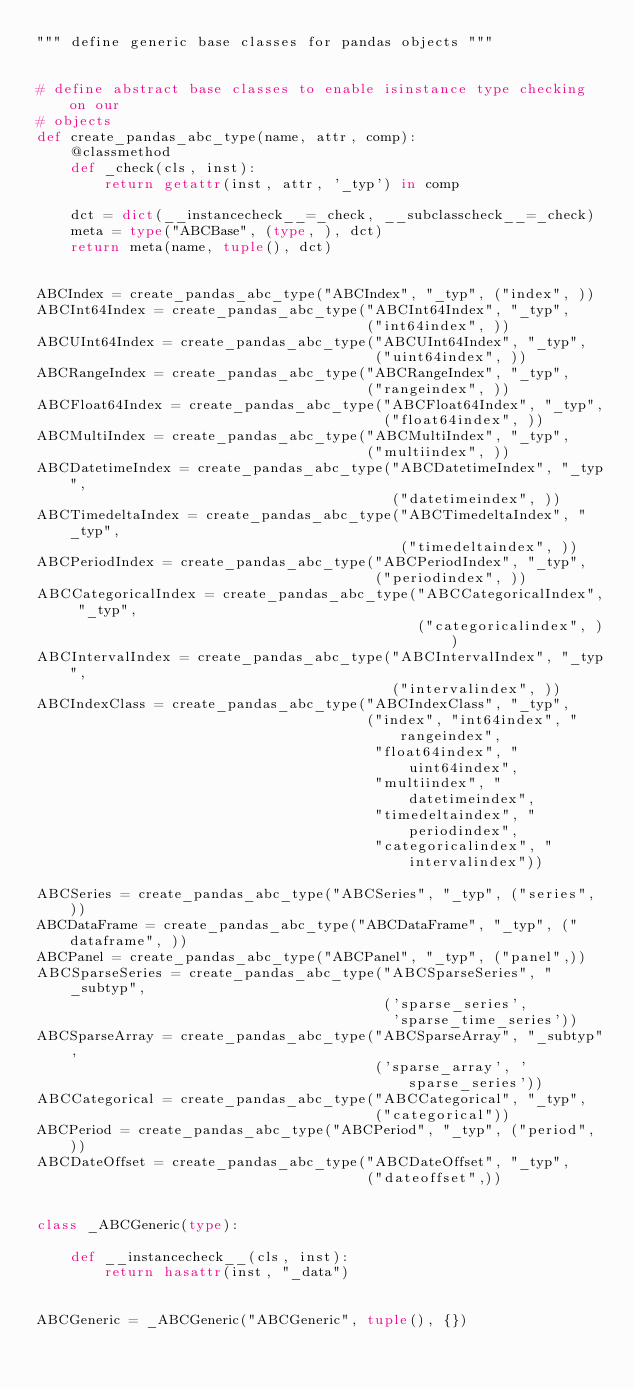<code> <loc_0><loc_0><loc_500><loc_500><_Python_>""" define generic base classes for pandas objects """


# define abstract base classes to enable isinstance type checking on our
# objects
def create_pandas_abc_type(name, attr, comp):
    @classmethod
    def _check(cls, inst):
        return getattr(inst, attr, '_typ') in comp

    dct = dict(__instancecheck__=_check, __subclasscheck__=_check)
    meta = type("ABCBase", (type, ), dct)
    return meta(name, tuple(), dct)


ABCIndex = create_pandas_abc_type("ABCIndex", "_typ", ("index", ))
ABCInt64Index = create_pandas_abc_type("ABCInt64Index", "_typ",
                                       ("int64index", ))
ABCUInt64Index = create_pandas_abc_type("ABCUInt64Index", "_typ",
                                        ("uint64index", ))
ABCRangeIndex = create_pandas_abc_type("ABCRangeIndex", "_typ",
                                       ("rangeindex", ))
ABCFloat64Index = create_pandas_abc_type("ABCFloat64Index", "_typ",
                                         ("float64index", ))
ABCMultiIndex = create_pandas_abc_type("ABCMultiIndex", "_typ",
                                       ("multiindex", ))
ABCDatetimeIndex = create_pandas_abc_type("ABCDatetimeIndex", "_typ",
                                          ("datetimeindex", ))
ABCTimedeltaIndex = create_pandas_abc_type("ABCTimedeltaIndex", "_typ",
                                           ("timedeltaindex", ))
ABCPeriodIndex = create_pandas_abc_type("ABCPeriodIndex", "_typ",
                                        ("periodindex", ))
ABCCategoricalIndex = create_pandas_abc_type("ABCCategoricalIndex", "_typ",
                                             ("categoricalindex", ))
ABCIntervalIndex = create_pandas_abc_type("ABCIntervalIndex", "_typ",
                                          ("intervalindex", ))
ABCIndexClass = create_pandas_abc_type("ABCIndexClass", "_typ",
                                       ("index", "int64index", "rangeindex",
                                        "float64index", "uint64index",
                                        "multiindex", "datetimeindex",
                                        "timedeltaindex", "periodindex",
                                        "categoricalindex", "intervalindex"))

ABCSeries = create_pandas_abc_type("ABCSeries", "_typ", ("series", ))
ABCDataFrame = create_pandas_abc_type("ABCDataFrame", "_typ", ("dataframe", ))
ABCPanel = create_pandas_abc_type("ABCPanel", "_typ", ("panel",))
ABCSparseSeries = create_pandas_abc_type("ABCSparseSeries", "_subtyp",
                                         ('sparse_series',
                                          'sparse_time_series'))
ABCSparseArray = create_pandas_abc_type("ABCSparseArray", "_subtyp",
                                        ('sparse_array', 'sparse_series'))
ABCCategorical = create_pandas_abc_type("ABCCategorical", "_typ",
                                        ("categorical"))
ABCPeriod = create_pandas_abc_type("ABCPeriod", "_typ", ("period", ))
ABCDateOffset = create_pandas_abc_type("ABCDateOffset", "_typ",
                                       ("dateoffset",))


class _ABCGeneric(type):

    def __instancecheck__(cls, inst):
        return hasattr(inst, "_data")


ABCGeneric = _ABCGeneric("ABCGeneric", tuple(), {})
</code> 